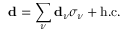Convert formula to latex. <formula><loc_0><loc_0><loc_500><loc_500>d = \sum _ { \nu } d _ { \nu } \sigma _ { \nu } + h . c .</formula> 